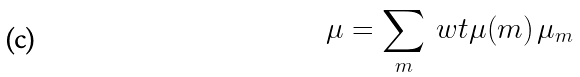Convert formula to latex. <formula><loc_0><loc_0><loc_500><loc_500>\mu = \sum _ { m } \ w t \mu ( m ) \, \mu _ { m }</formula> 